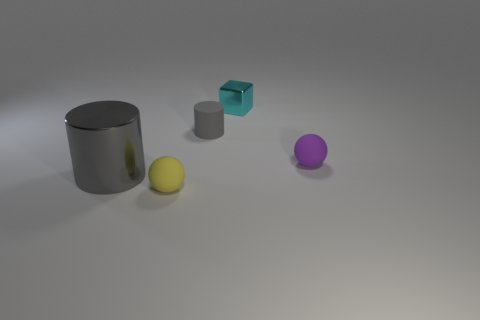Are there any other things that are the same size as the gray metal cylinder?
Ensure brevity in your answer.  No. Are there any other things that are the same shape as the large gray metallic object?
Your answer should be very brief. Yes. Do the big cylinder in front of the small cyan thing and the small purple ball have the same material?
Offer a very short reply. No. What number of other objects are there of the same color as the rubber cylinder?
Make the answer very short. 1. Is the color of the large metallic cylinder the same as the tiny rubber cylinder?
Give a very brief answer. Yes. There is a gray thing behind the gray cylinder in front of the tiny matte cylinder; how big is it?
Give a very brief answer. Small. Are the small thing that is on the right side of the tiny block and the tiny object on the left side of the tiny gray object made of the same material?
Give a very brief answer. Yes. There is a object that is left of the tiny yellow thing; does it have the same color as the tiny shiny thing?
Keep it short and to the point. No. What number of tiny metallic objects are on the left side of the purple matte ball?
Ensure brevity in your answer.  1. Is the small cylinder made of the same material as the gray object in front of the tiny rubber cylinder?
Your answer should be very brief. No. 